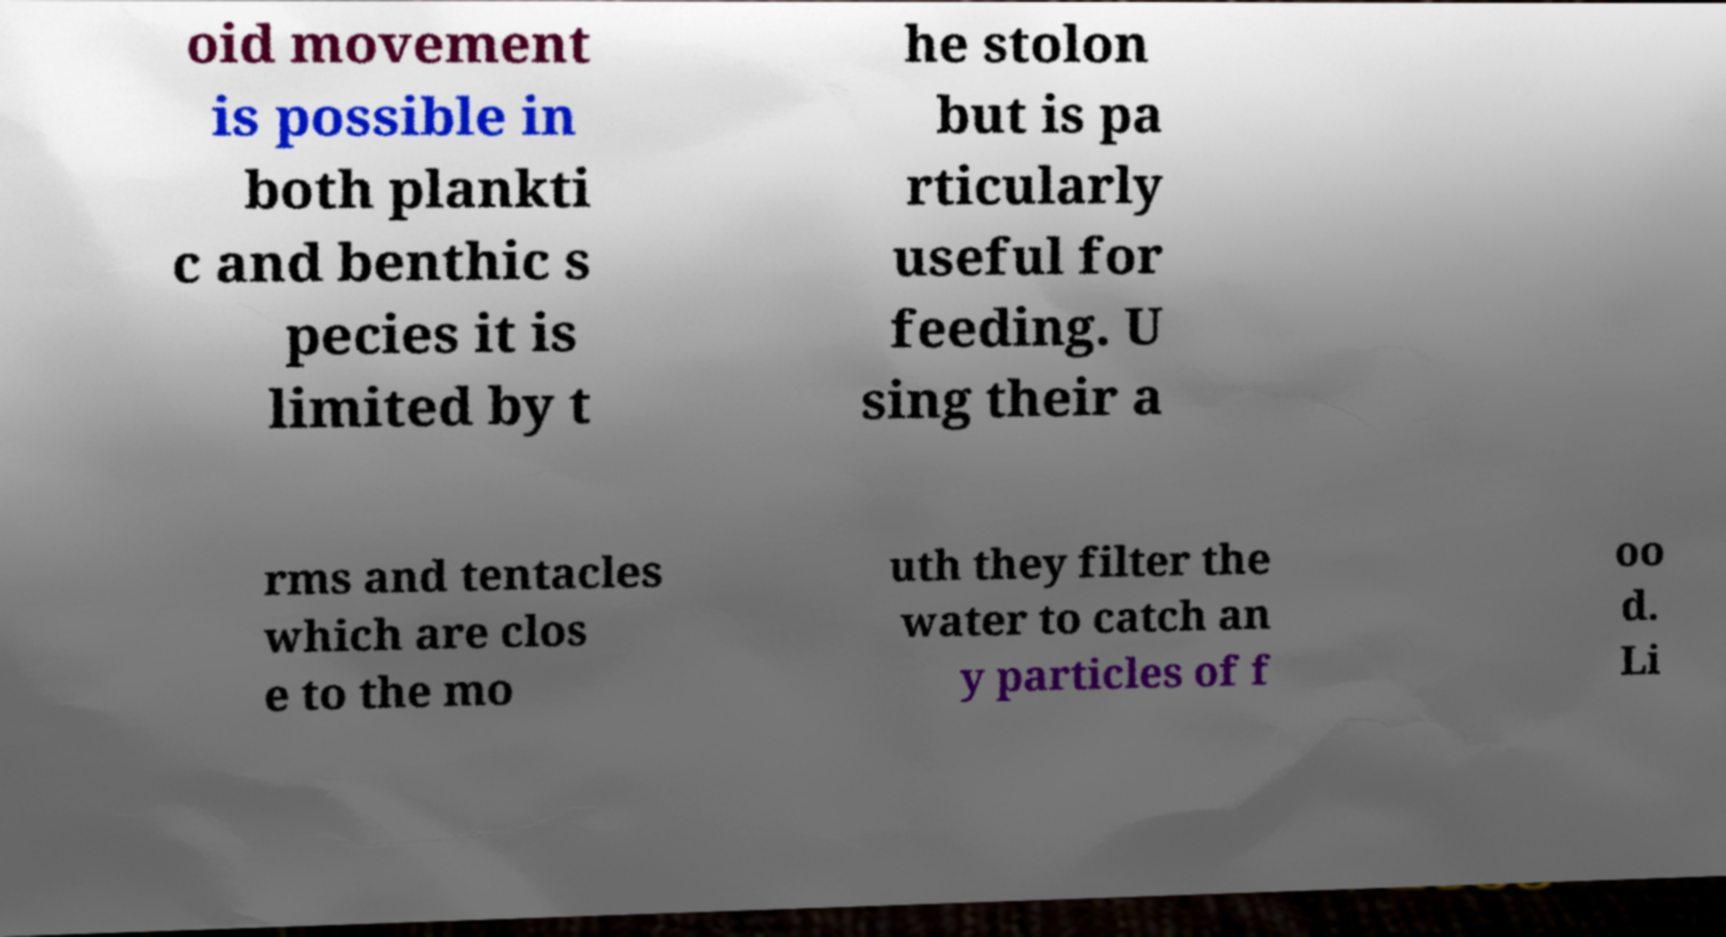There's text embedded in this image that I need extracted. Can you transcribe it verbatim? oid movement is possible in both plankti c and benthic s pecies it is limited by t he stolon but is pa rticularly useful for feeding. U sing their a rms and tentacles which are clos e to the mo uth they filter the water to catch an y particles of f oo d. Li 